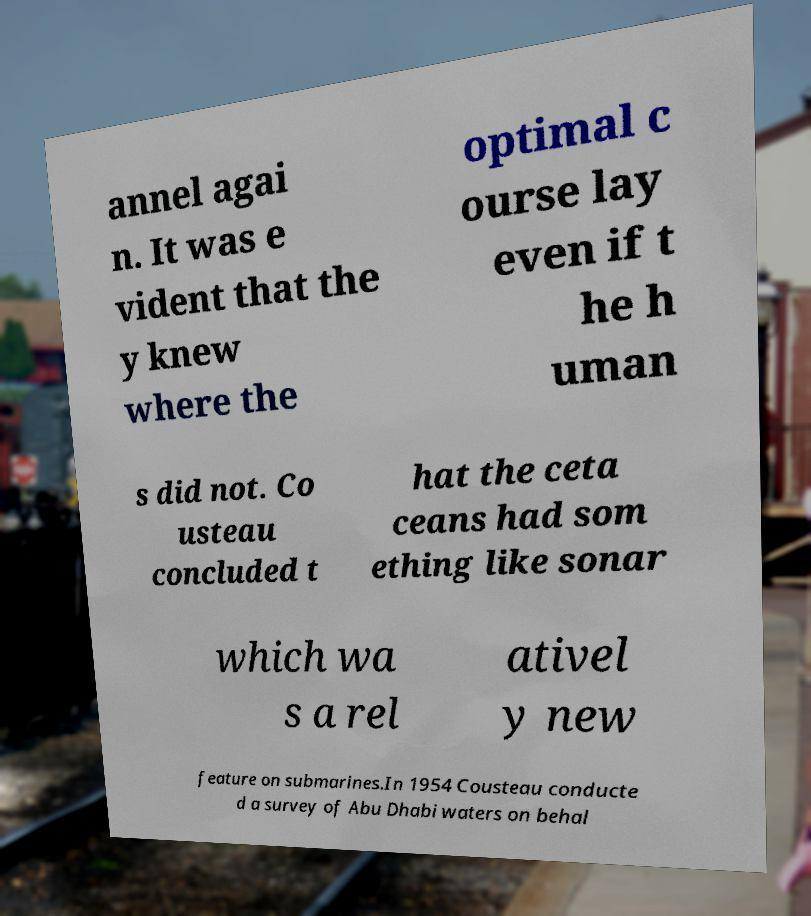Could you assist in decoding the text presented in this image and type it out clearly? annel agai n. It was e vident that the y knew where the optimal c ourse lay even if t he h uman s did not. Co usteau concluded t hat the ceta ceans had som ething like sonar which wa s a rel ativel y new feature on submarines.In 1954 Cousteau conducte d a survey of Abu Dhabi waters on behal 